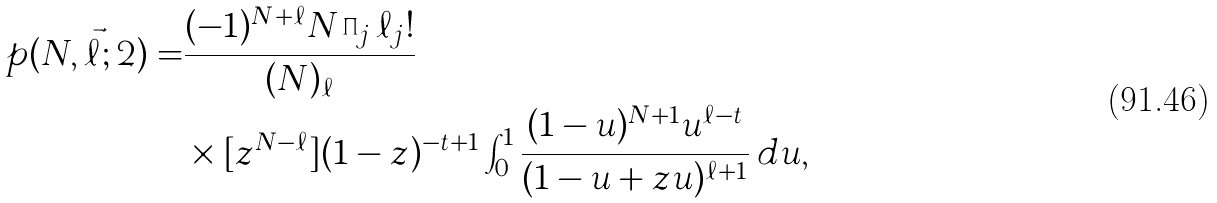Convert formula to latex. <formula><loc_0><loc_0><loc_500><loc_500>p ( N , \vec { \ell } ; 2 ) = & \frac { ( - 1 ) ^ { N + \ell } N \prod _ { j } \ell _ { j } ! } { ( N ) _ { \ell } } \\ & \times [ z ^ { N - \ell } ] ( 1 - z ) ^ { - t + 1 } \int _ { 0 } ^ { 1 } \frac { ( 1 - u ) ^ { N + 1 } u ^ { \ell - t } } { ( 1 - u + z u ) ^ { \ell + 1 } } \, d u ,</formula> 